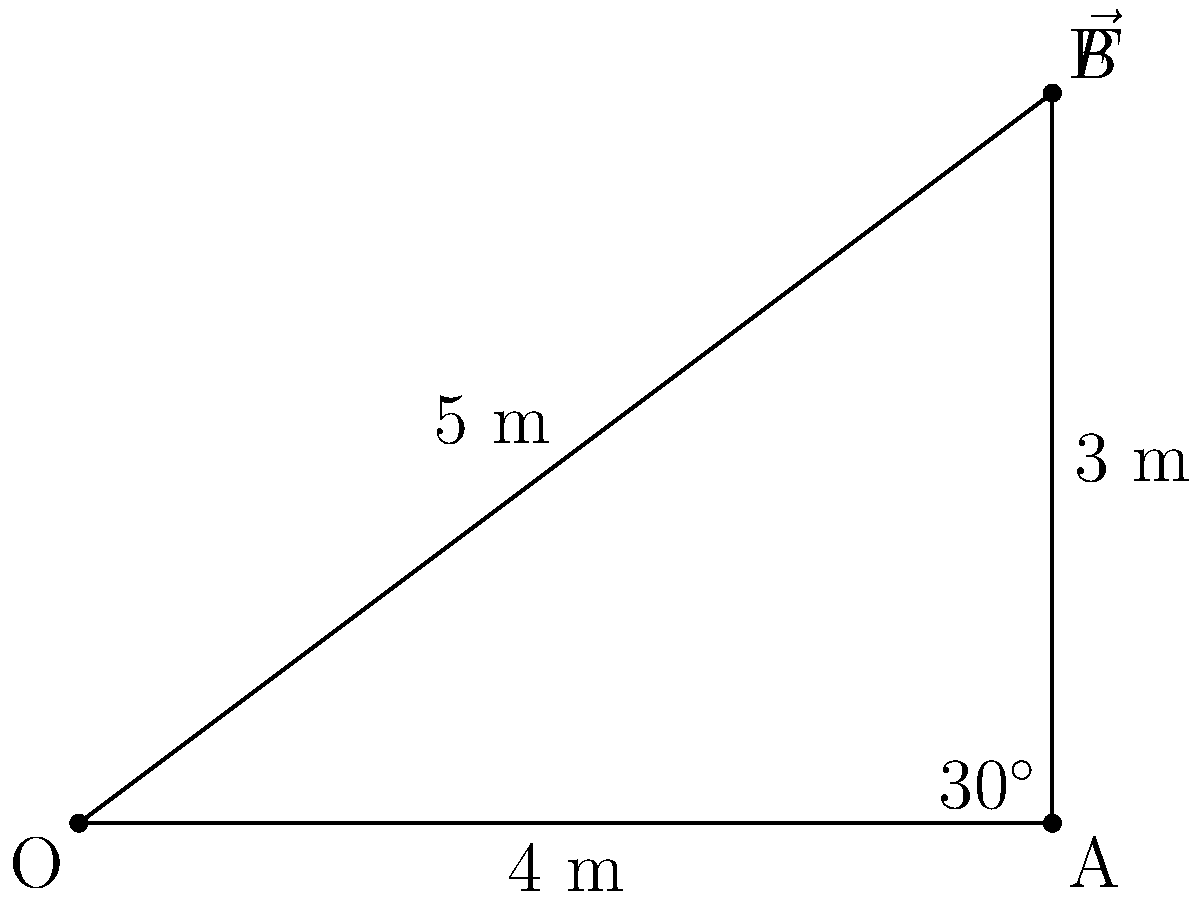A veterinarian needs to move a 500 kg horse using a rope attached to its halter. The rope makes a 30° angle with the horizontal, and the horse is initially at rest on a frictionless surface. If the veterinarian applies a force $\vec{F}$ with a magnitude of 1000 N along the rope, what is the magnitude of the horizontal component of the force that actually moves the horse forward? Let's approach this step-by-step:

1) First, we need to understand that the force moving the horse forward is the horizontal component of the applied force $\vec{F}$.

2) We can use trigonometry to find this horizontal component. In a right-angled triangle, the adjacent side to the given angle represents the horizontal component we're looking for.

3) The relationship between the hypotenuse (total force) and the adjacent side (horizontal component) is given by the cosine function:

   $F_x = F \cos \theta$

   Where $F_x$ is the horizontal component, $F$ is the total force, and $\theta$ is the angle with the horizontal.

4) We're given:
   $F = 1000$ N
   $\theta = 30°$

5) Plugging these values into our equation:

   $F_x = 1000 \cos 30°$

6) $\cos 30° = \frac{\sqrt{3}}{2} \approx 0.866$

7) Therefore:
   $F_x = 1000 \cdot 0.866 = 866$ N

Thus, the magnitude of the horizontal component of the force is approximately 866 N.
Answer: 866 N 